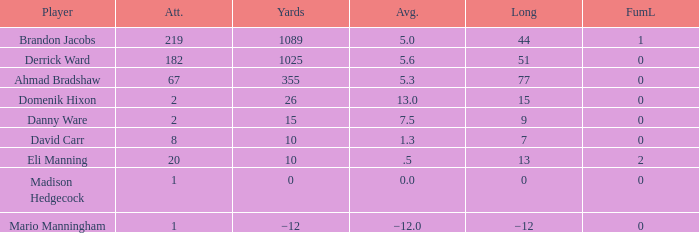What is the mean rushing distance per attempt by domenik hixon? 13.0. 